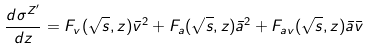Convert formula to latex. <formula><loc_0><loc_0><loc_500><loc_500>\frac { d \sigma ^ { Z ^ { \prime } } } { d z } = F _ { v } ( \sqrt { s } , z ) \bar { v } ^ { 2 } + F _ { a } ( \sqrt { s } , z ) \bar { a } ^ { 2 } + F _ { a v } ( \sqrt { s } , z ) \bar { a } \bar { v }</formula> 